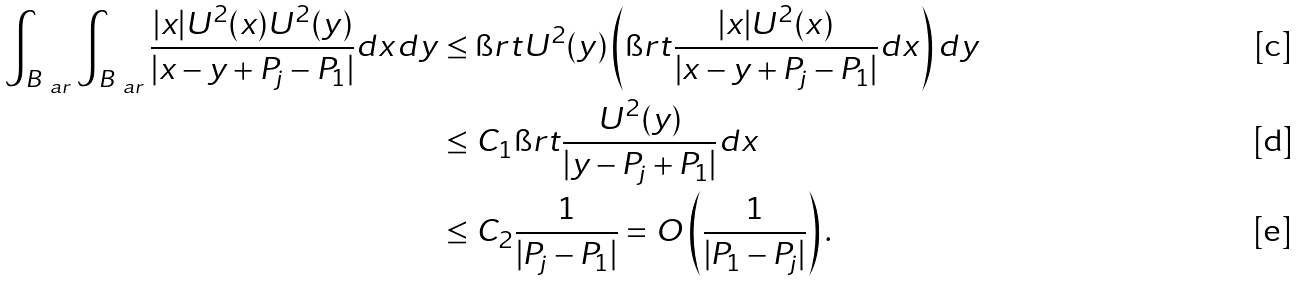<formula> <loc_0><loc_0><loc_500><loc_500>\int _ { B _ { \ a r } } \int _ { B _ { \ a r } } \frac { | x | U ^ { 2 } ( x ) U ^ { 2 } ( y ) } { | x - y + P _ { j } - P _ { 1 } | } d x d y & \leq \i r t U ^ { 2 } ( y ) \left ( \i r t \frac { | x | U ^ { 2 } ( x ) } { | x - y + P _ { j } - P _ { 1 } | } d x \right ) d y \\ & \leq C _ { 1 } \i r t \frac { U ^ { 2 } ( y ) } { | y - P _ { j } + P _ { 1 } | } d x \\ & \leq C _ { 2 } \frac { 1 } { | P _ { j } - P _ { 1 } | } = O \left ( \frac { 1 } { | P _ { 1 } - P _ { j } | } \right ) .</formula> 